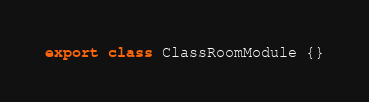Convert code to text. <code><loc_0><loc_0><loc_500><loc_500><_TypeScript_>export class ClassRoomModule {}
</code> 